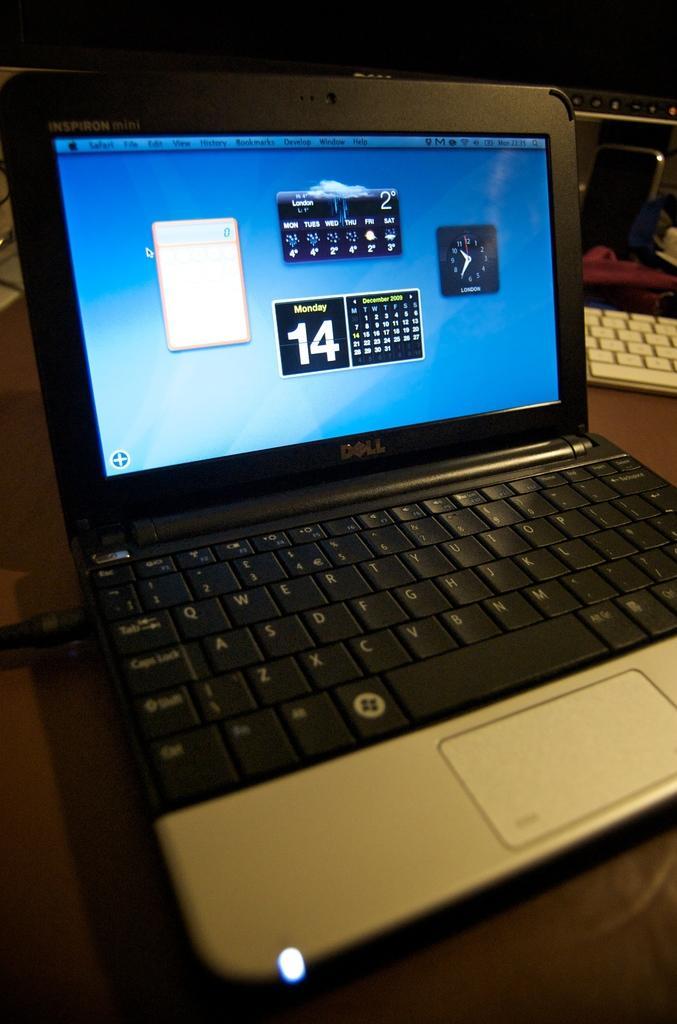Describe this image in one or two sentences. There is a laptop on a table. On the screen of the laptop we can see some icons. In the background there is another laptop on the table. 